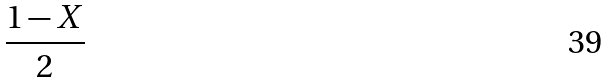Convert formula to latex. <formula><loc_0><loc_0><loc_500><loc_500>\frac { 1 - X } { 2 }</formula> 